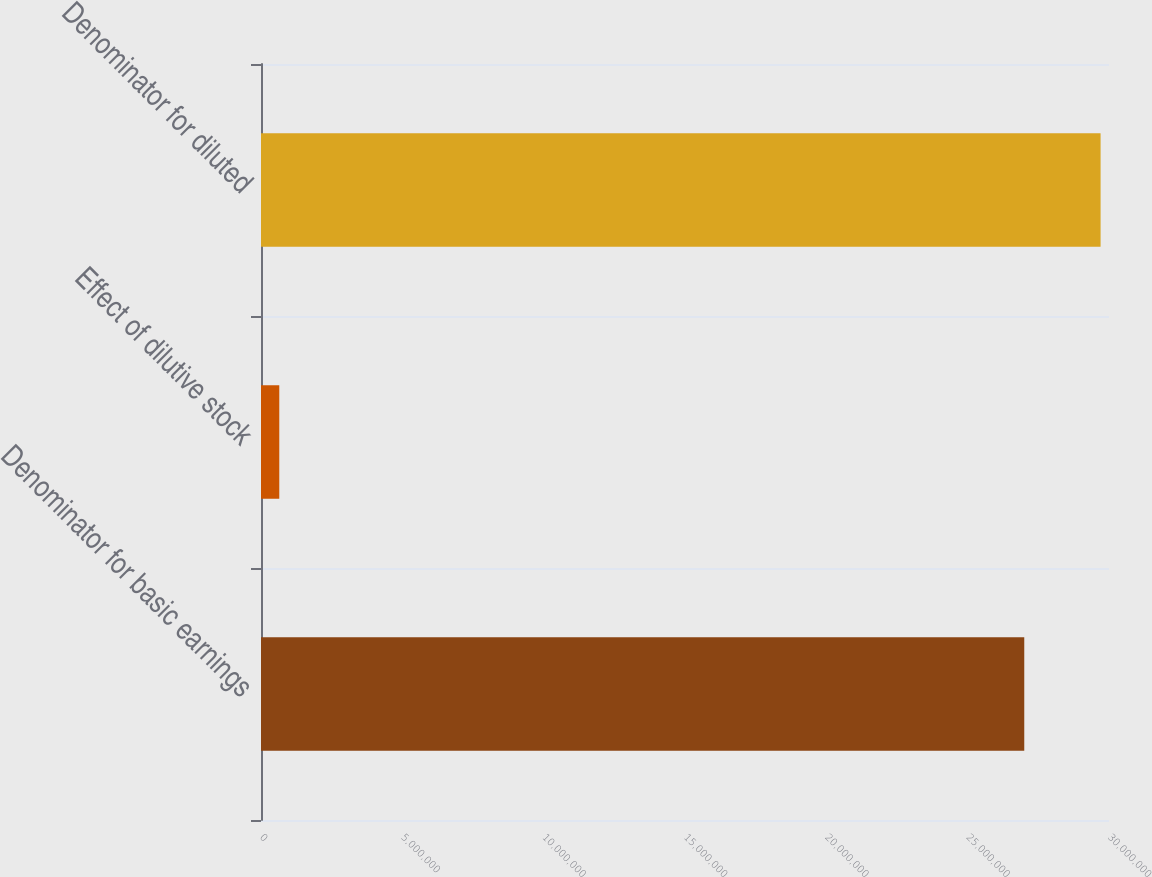Convert chart to OTSL. <chart><loc_0><loc_0><loc_500><loc_500><bar_chart><fcel>Denominator for basic earnings<fcel>Effect of dilutive stock<fcel>Denominator for diluted<nl><fcel>2.70021e+07<fcel>646964<fcel>2.97023e+07<nl></chart> 